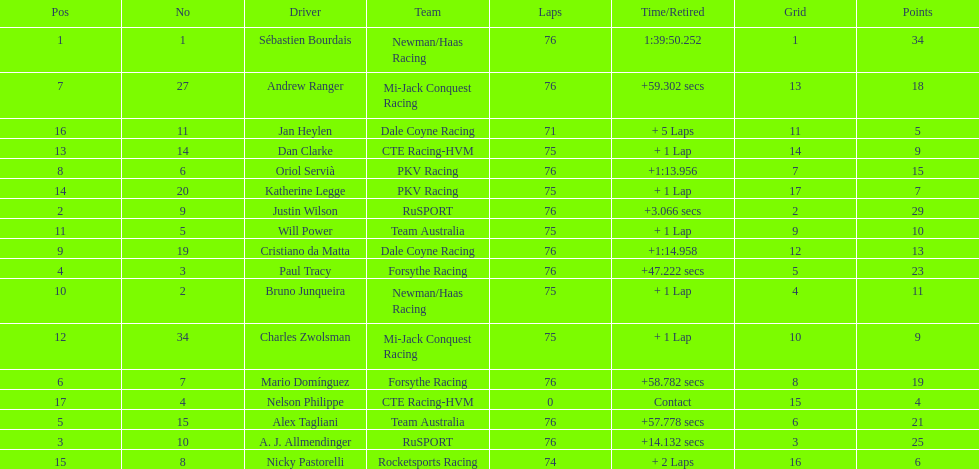What is the total point difference between the driver who received the most points and the driver who received the least? 30. 